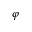Convert formula to latex. <formula><loc_0><loc_0><loc_500><loc_500>\varphi</formula> 